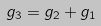<formula> <loc_0><loc_0><loc_500><loc_500>g _ { 3 } = g _ { 2 } + g _ { 1 }</formula> 